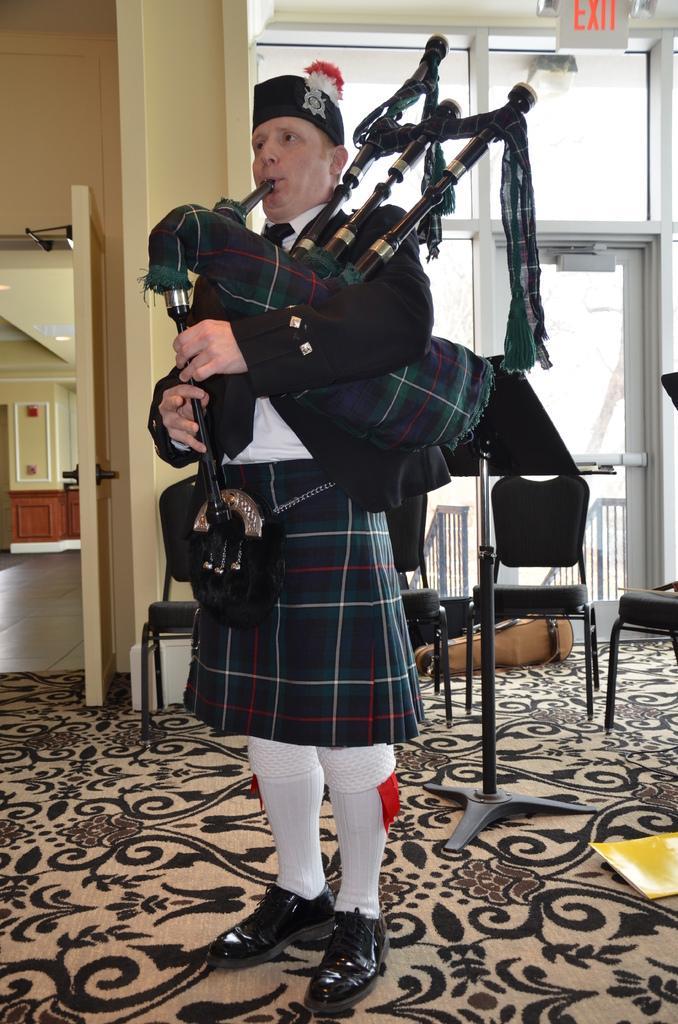Could you give a brief overview of what you see in this image? In this picture we can see a person playing trombone, behind we can see door to the wall. 